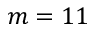<formula> <loc_0><loc_0><loc_500><loc_500>m = 1 1</formula> 